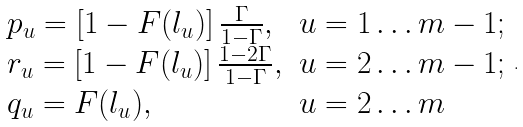<formula> <loc_0><loc_0><loc_500><loc_500>\begin{array} { l l } p _ { u } = \left [ 1 - F ( l _ { u } ) \right ] \frac { \Gamma } { 1 - \Gamma } , & u = 1 \dots m - 1 ; \\ r _ { u } = \left [ 1 - F ( l _ { u } ) \right ] \frac { 1 - 2 \Gamma } { 1 - \Gamma } , & u = 2 \dots m - 1 ; \\ q _ { u } = F ( l _ { u } ) , & u = 2 \dots m \end{array} .</formula> 